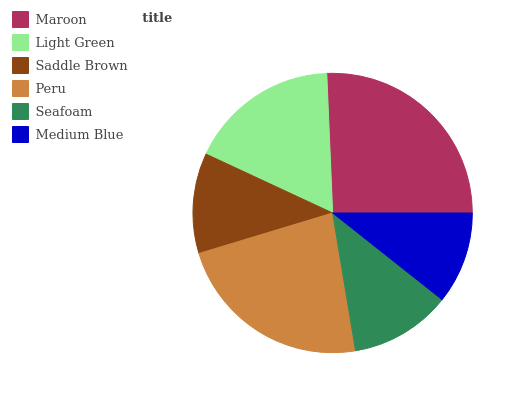Is Medium Blue the minimum?
Answer yes or no. Yes. Is Maroon the maximum?
Answer yes or no. Yes. Is Light Green the minimum?
Answer yes or no. No. Is Light Green the maximum?
Answer yes or no. No. Is Maroon greater than Light Green?
Answer yes or no. Yes. Is Light Green less than Maroon?
Answer yes or no. Yes. Is Light Green greater than Maroon?
Answer yes or no. No. Is Maroon less than Light Green?
Answer yes or no. No. Is Light Green the high median?
Answer yes or no. Yes. Is Seafoam the low median?
Answer yes or no. Yes. Is Seafoam the high median?
Answer yes or no. No. Is Light Green the low median?
Answer yes or no. No. 